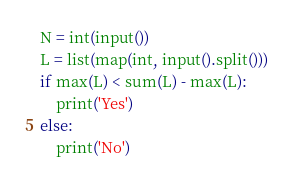<code> <loc_0><loc_0><loc_500><loc_500><_Python_>N = int(input())
L = list(map(int, input().split()))
if max(L) < sum(L) - max(L):
    print('Yes')
else:
    print('No')
</code> 